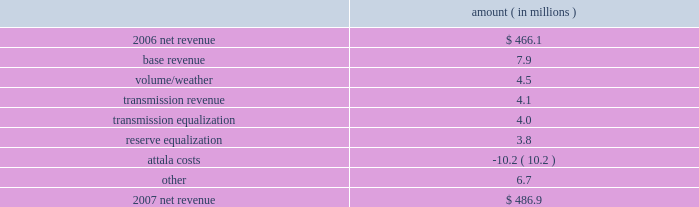Entergy mississippi , inc .
Management's financial discussion and analysis the net wholesale revenue variance is primarily due to lower profit on joint account sales and reduced capacity revenue from the municipal energy agency of mississippi .
Gross operating revenues , fuel and purchased power expenses , and other regulatory charges gross operating revenues increased primarily due to an increase of $ 152.5 million in fuel cost recovery revenues due to higher fuel rates , partially offset by a decrease of $ 43 million in gross wholesale revenues due to a decrease in net generation and purchases in excess of decreased net area demand resulting in less energy available for resale sales coupled with a decrease in system agreement remedy receipts .
Fuel and purchased power expenses increased primarily due to increases in the average market prices of natural gas and purchased power , partially offset by decreased demand and decreased recovery from customers of deferred fuel costs .
Other regulatory charges increased primarily due to increased recovery through the grand gulf rider of grand gulf capacity costs due to higher rates and increased recovery of costs associated with the power management recovery rider .
There is no material effect on net income due to quarterly adjustments to the power management recovery rider .
2007 compared to 2006 net revenue consists of operating revenues net of : 1 ) fuel , fuel-related expenses , and gas purchased for resale , 2 ) purchased power expenses , and 3 ) other regulatory charges ( credits ) .
Following is an analysis of the change in net revenue comparing 2007 to 2006 .
Amount ( in millions ) .
The base revenue variance is primarily due to a formula rate plan increase effective july 2007 .
The formula rate plan filing is discussed further in "state and local rate regulation" below .
The volume/weather variance is primarily due to increased electricity usage primarily in the residential and commercial sectors , including the effect of more favorable weather on billed electric sales in 2007 compared to 2006 .
Billed electricity usage increased 214 gwh .
The increase in usage was partially offset by decreased usage in the industrial sector .
The transmission revenue variance is due to higher rates and the addition of new transmission customers in late 2006 .
The transmission equalization variance is primarily due to a revision made in 2006 of transmission equalization receipts among entergy companies .
The reserve equalization variance is primarily due to a revision in 2006 of reserve equalization payments among entergy companies due to a ferc ruling regarding the inclusion of interruptible loads in reserve .
What is the percentage change in net revenue in 2007 compare to 2006? 
Computations: ((486.9 - 466.1) / 466.1)
Answer: 0.04463. 